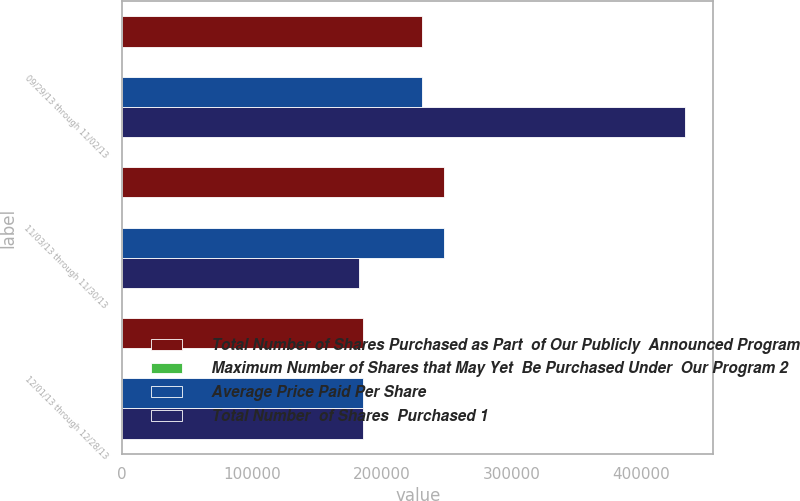Convert chart to OTSL. <chart><loc_0><loc_0><loc_500><loc_500><stacked_bar_chart><ecel><fcel>09/29/13 through 11/02/13<fcel>11/03/13 through 11/30/13<fcel>12/01/13 through 12/28/13<nl><fcel>Total Number of Shares Purchased as Part  of Our Publicly  Announced Program<fcel>231000<fcel>248057<fcel>185300<nl><fcel>Maximum Number of Shares that May Yet  Be Purchased Under  Our Program 2<fcel>107.78<fcel>112.54<fcel>113.11<nl><fcel>Average Price Paid Per Share<fcel>231000<fcel>248057<fcel>185300<nl><fcel>Total Number  of Shares  Purchased 1<fcel>433702<fcel>182662<fcel>185300<nl></chart> 